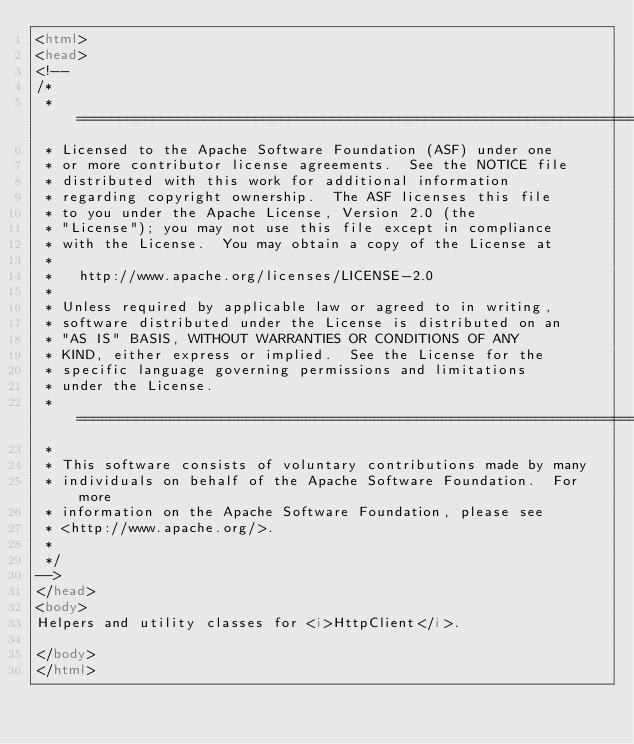<code> <loc_0><loc_0><loc_500><loc_500><_HTML_><html>
<head>
<!--
/*
 * ====================================================================
 * Licensed to the Apache Software Foundation (ASF) under one
 * or more contributor license agreements.  See the NOTICE file
 * distributed with this work for additional information
 * regarding copyright ownership.  The ASF licenses this file
 * to you under the Apache License, Version 2.0 (the
 * "License"); you may not use this file except in compliance
 * with the License.  You may obtain a copy of the License at
 *
 *   http://www.apache.org/licenses/LICENSE-2.0
 *
 * Unless required by applicable law or agreed to in writing,
 * software distributed under the License is distributed on an
 * "AS IS" BASIS, WITHOUT WARRANTIES OR CONDITIONS OF ANY
 * KIND, either express or implied.  See the License for the
 * specific language governing permissions and limitations
 * under the License.
 * ====================================================================
 *
 * This software consists of voluntary contributions made by many
 * individuals on behalf of the Apache Software Foundation.  For more
 * information on the Apache Software Foundation, please see
 * <http://www.apache.org/>.
 *
 */
-->
</head>
<body>
Helpers and utility classes for <i>HttpClient</i>.

</body>
</html>
</code> 